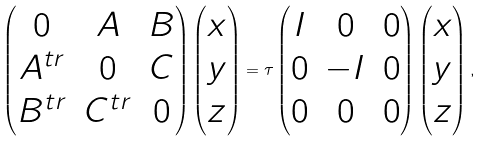Convert formula to latex. <formula><loc_0><loc_0><loc_500><loc_500>\begin{pmatrix} 0 & A & B \\ A ^ { t r } & 0 & C \\ B ^ { t r } & C ^ { t r } & 0 \end{pmatrix} \begin{pmatrix} x \\ y \\ z \end{pmatrix} = \tau \begin{pmatrix} I & 0 & 0 \\ 0 & - I & 0 \\ 0 & 0 & 0 \end{pmatrix} \begin{pmatrix} x \\ y \\ z \end{pmatrix} ,</formula> 